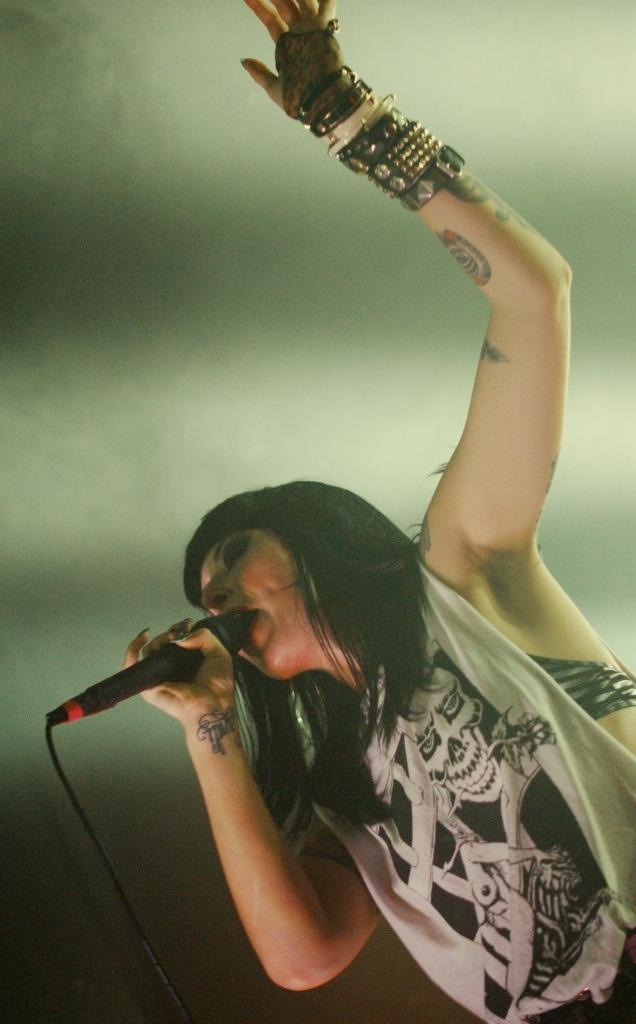In one or two sentences, can you explain what this image depicts? This is a picture of a woman in white dress, she is holding a microphone and singing. 